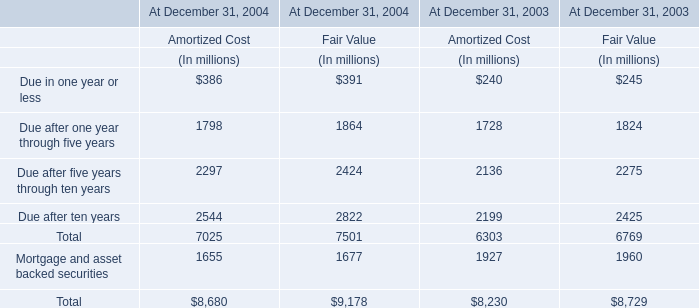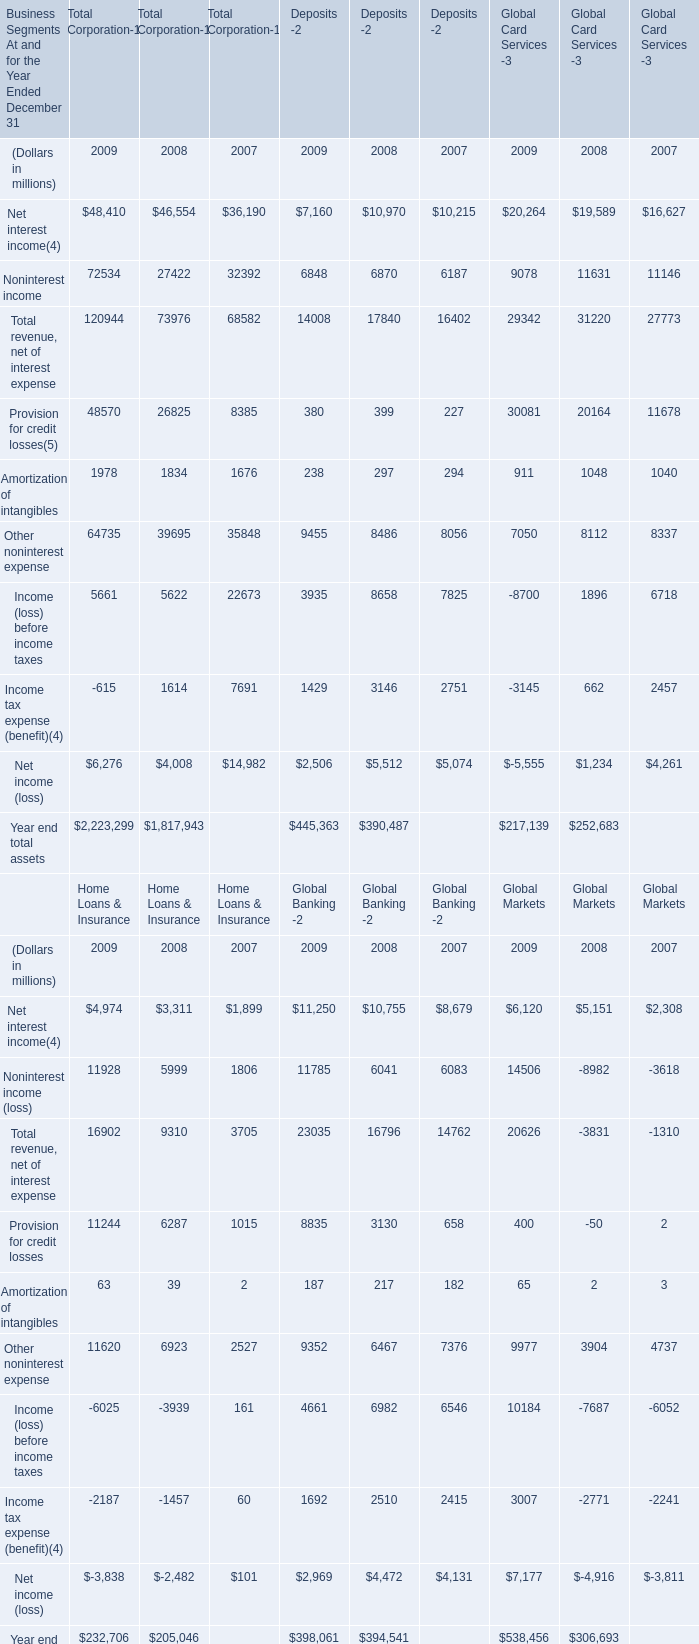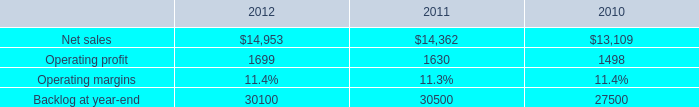what was the percent of net sales attributable to the f-35 lrip contracts included in the 2012 sales 
Computations: (745 / 14953)
Answer: 0.04982. 